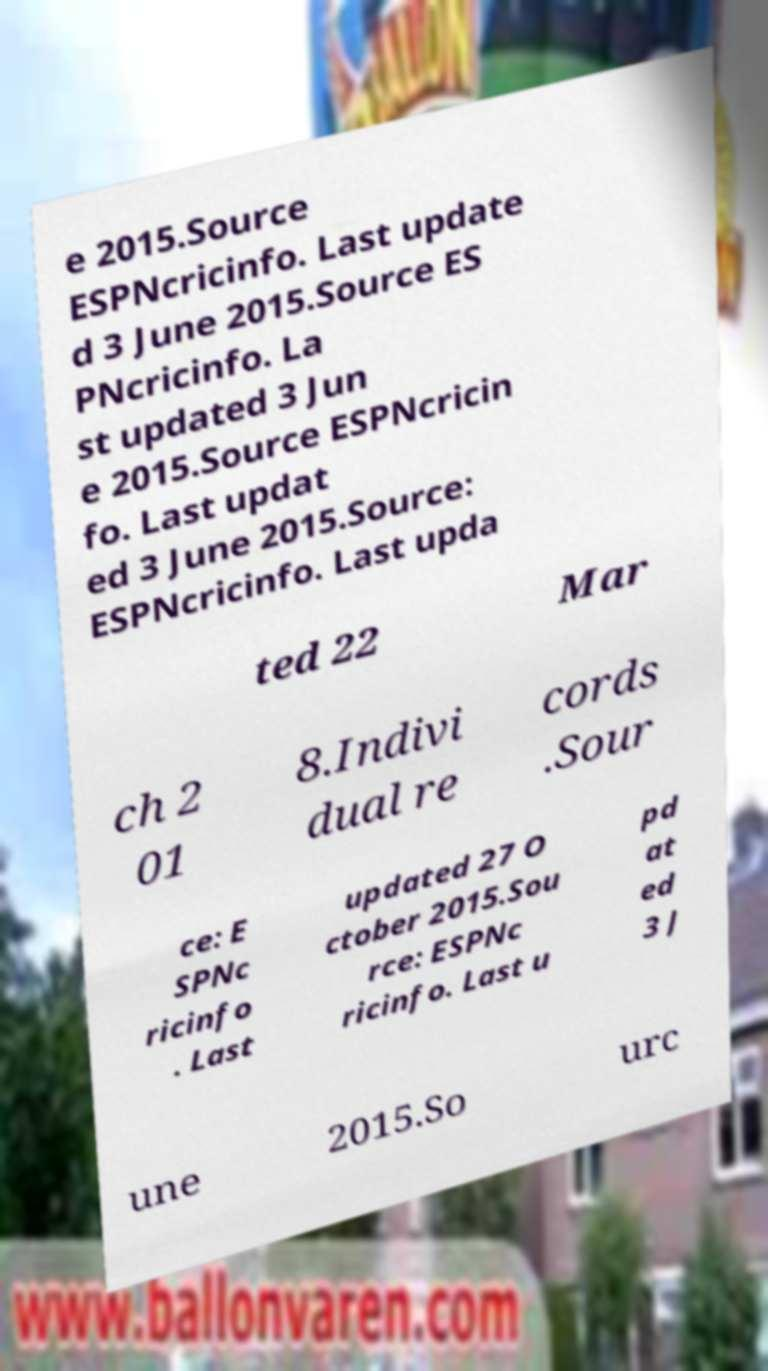Please identify and transcribe the text found in this image. e 2015.Source ESPNcricinfo. Last update d 3 June 2015.Source ES PNcricinfo. La st updated 3 Jun e 2015.Source ESPNcricin fo. Last updat ed 3 June 2015.Source: ESPNcricinfo. Last upda ted 22 Mar ch 2 01 8.Indivi dual re cords .Sour ce: E SPNc ricinfo . Last updated 27 O ctober 2015.Sou rce: ESPNc ricinfo. Last u pd at ed 3 J une 2015.So urc 